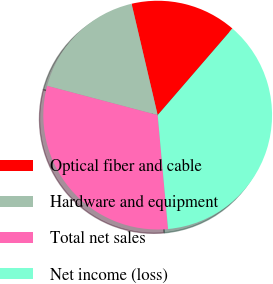Convert chart. <chart><loc_0><loc_0><loc_500><loc_500><pie_chart><fcel>Optical fiber and cable<fcel>Hardware and equipment<fcel>Total net sales<fcel>Net income (loss)<nl><fcel>15.0%<fcel>17.22%<fcel>30.57%<fcel>37.22%<nl></chart> 